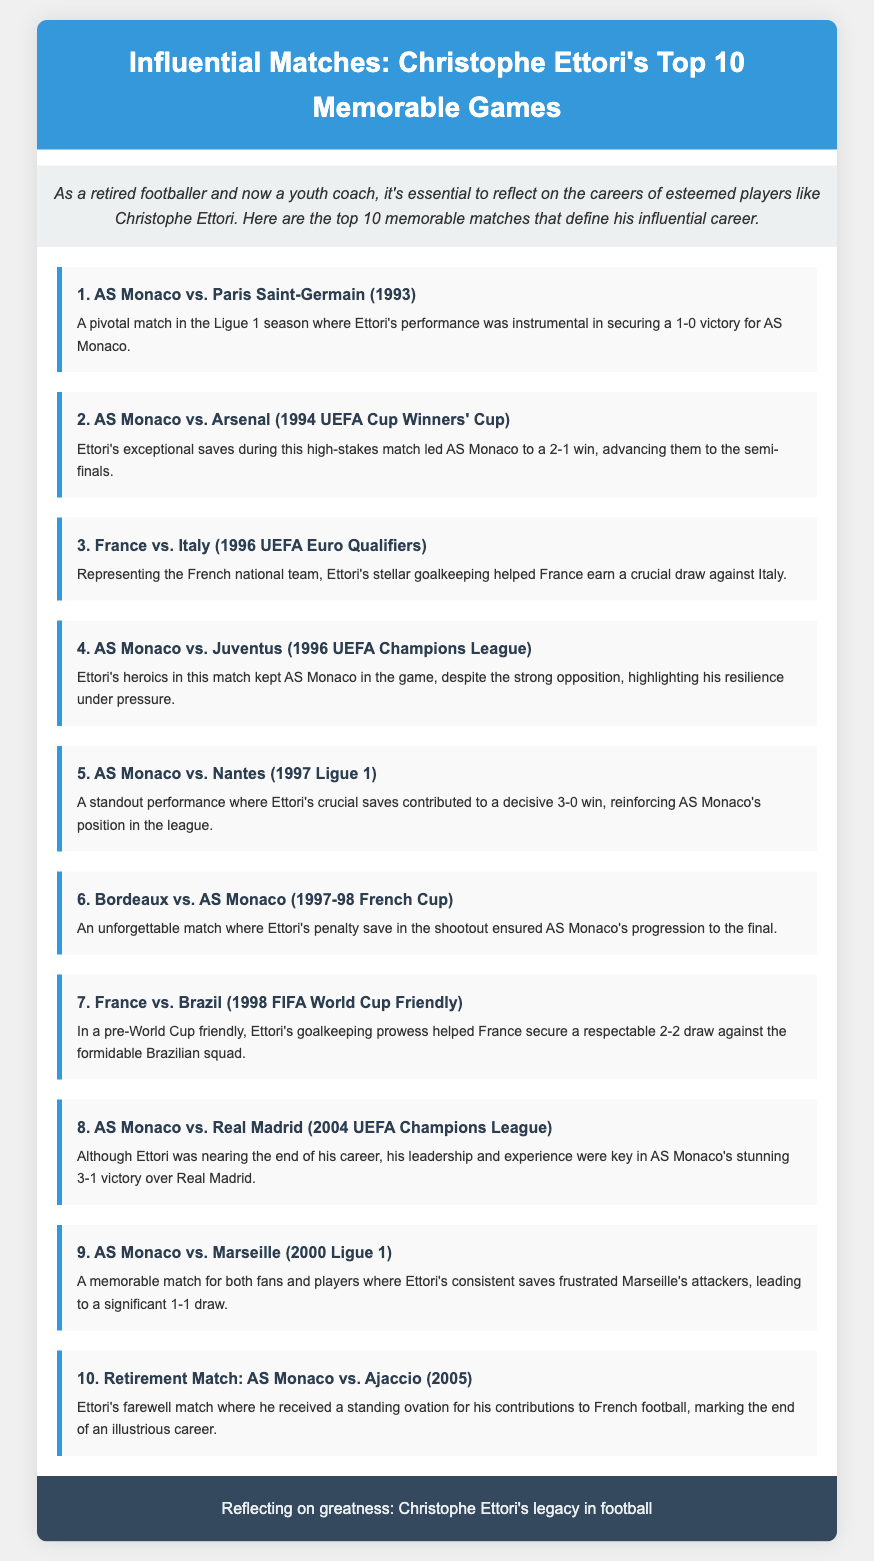What was the score in the AS Monaco vs. Paris Saint-Germain match? The document states that AS Monaco secured a 1-0 victory in this match.
Answer: 1-0 In which year did Christophe Ettori retire? The document mentions his retirement match against Ajaccio was in 2005.
Answer: 2005 How many memorable matches are listed in the document? There are a total of 10 memorable matches highlighted in the list.
Answer: 10 Which team did AS Monaco play against in the 1994 UEFA Cup Winners' Cup? The document indicates AS Monaco played against Arsenal in this match.
Answer: Arsenal What action did Ettori perform during the shootout against Bordeaux? It is noted that Ettori made a penalty save during the shootout in this match.
Answer: Penalty save Which team did Ettori represent in the 1996 UEFA Euro Qualifiers? The document states that he represented the French national team in this match.
Answer: France What was the outcome of the AS Monaco vs. Real Madrid match? The document highlights that AS Monaco achieved a stunning 3-1 victory over Real Madrid.
Answer: 3-1 victory Which match received a standing ovation for Ettori's farewell? The retirement match against Ajaccio is noted as the occasion where he received a standing ovation.
Answer: AS Monaco vs. Ajaccio What was a significant performance highlighted in the 1997 Ligue 1 match against Nantes? It mentions that Ettori's crucial saves contributed to a decisive 3-0 win.
Answer: 3-0 win 